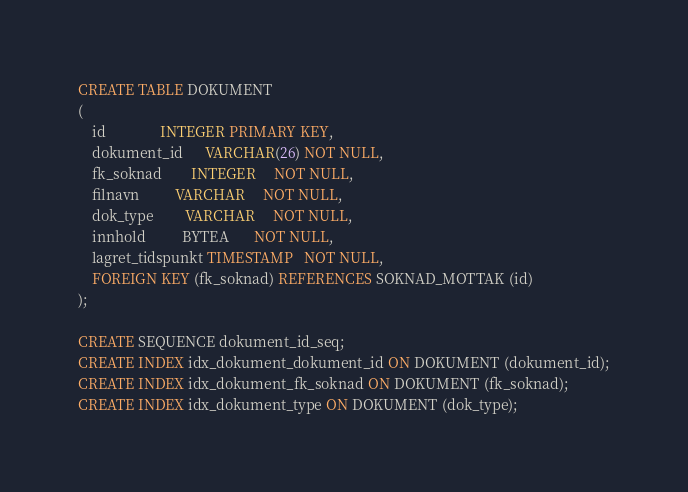<code> <loc_0><loc_0><loc_500><loc_500><_SQL_>CREATE TABLE DOKUMENT
(
    id               INTEGER PRIMARY KEY,
    dokument_id      VARCHAR(26) NOT NULL,
    fk_soknad        INTEGER     NOT NULL,
    filnavn          VARCHAR     NOT NULL,
    dok_type         VARCHAR     NOT NULL,
    innhold          BYTEA       NOT NULL,
    lagret_tidspunkt TIMESTAMP   NOT NULL,
    FOREIGN KEY (fk_soknad) REFERENCES SOKNAD_MOTTAK (id)
);

CREATE SEQUENCE dokument_id_seq;
CREATE INDEX idx_dokument_dokument_id ON DOKUMENT (dokument_id);
CREATE INDEX idx_dokument_fk_soknad ON DOKUMENT (fk_soknad);
CREATE INDEX idx_dokument_type ON DOKUMENT (dok_type);
</code> 